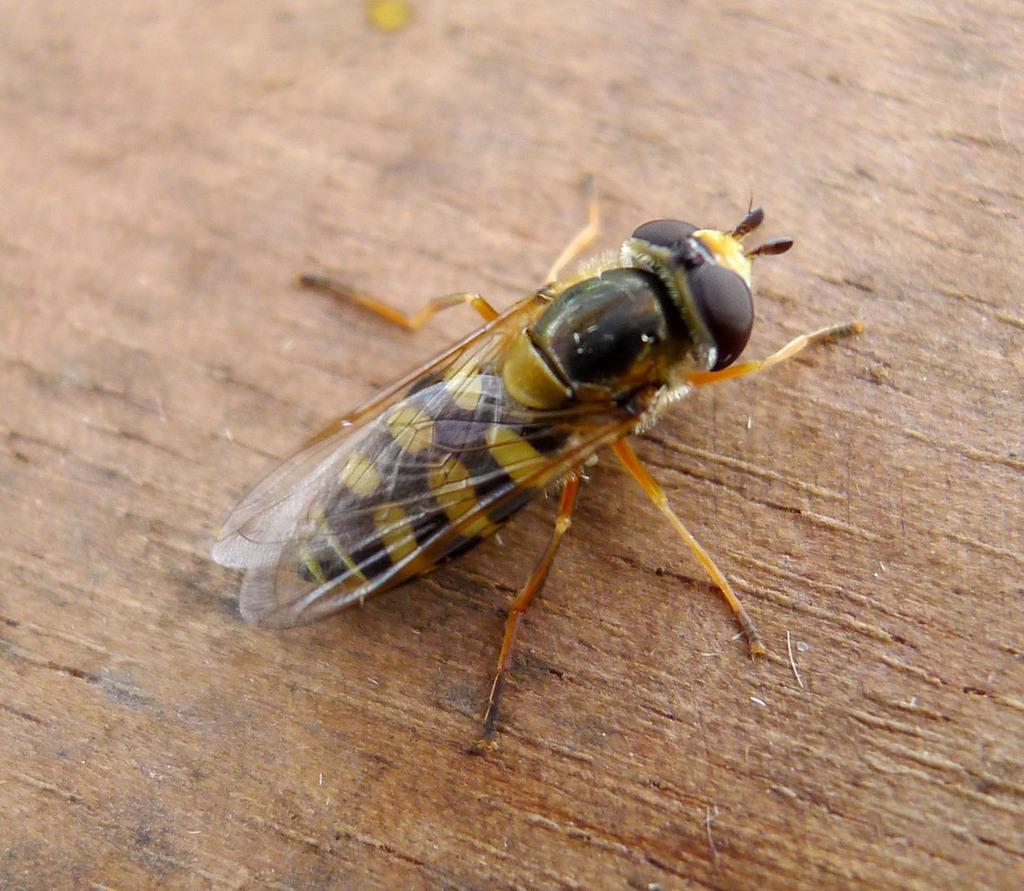Could you give a brief overview of what you see in this image? In this picture we can observe a honey bee which is in black and yellow color. This insect is on the brown color surface. 